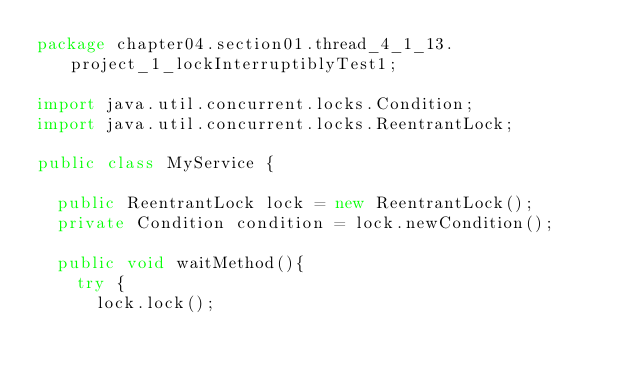<code> <loc_0><loc_0><loc_500><loc_500><_Java_>package chapter04.section01.thread_4_1_13.project_1_lockInterruptiblyTest1;

import java.util.concurrent.locks.Condition;
import java.util.concurrent.locks.ReentrantLock;

public class MyService {

	public ReentrantLock lock = new ReentrantLock();
	private Condition condition = lock.newCondition();

	public void waitMethod(){
		try {
			lock.lock();</code> 